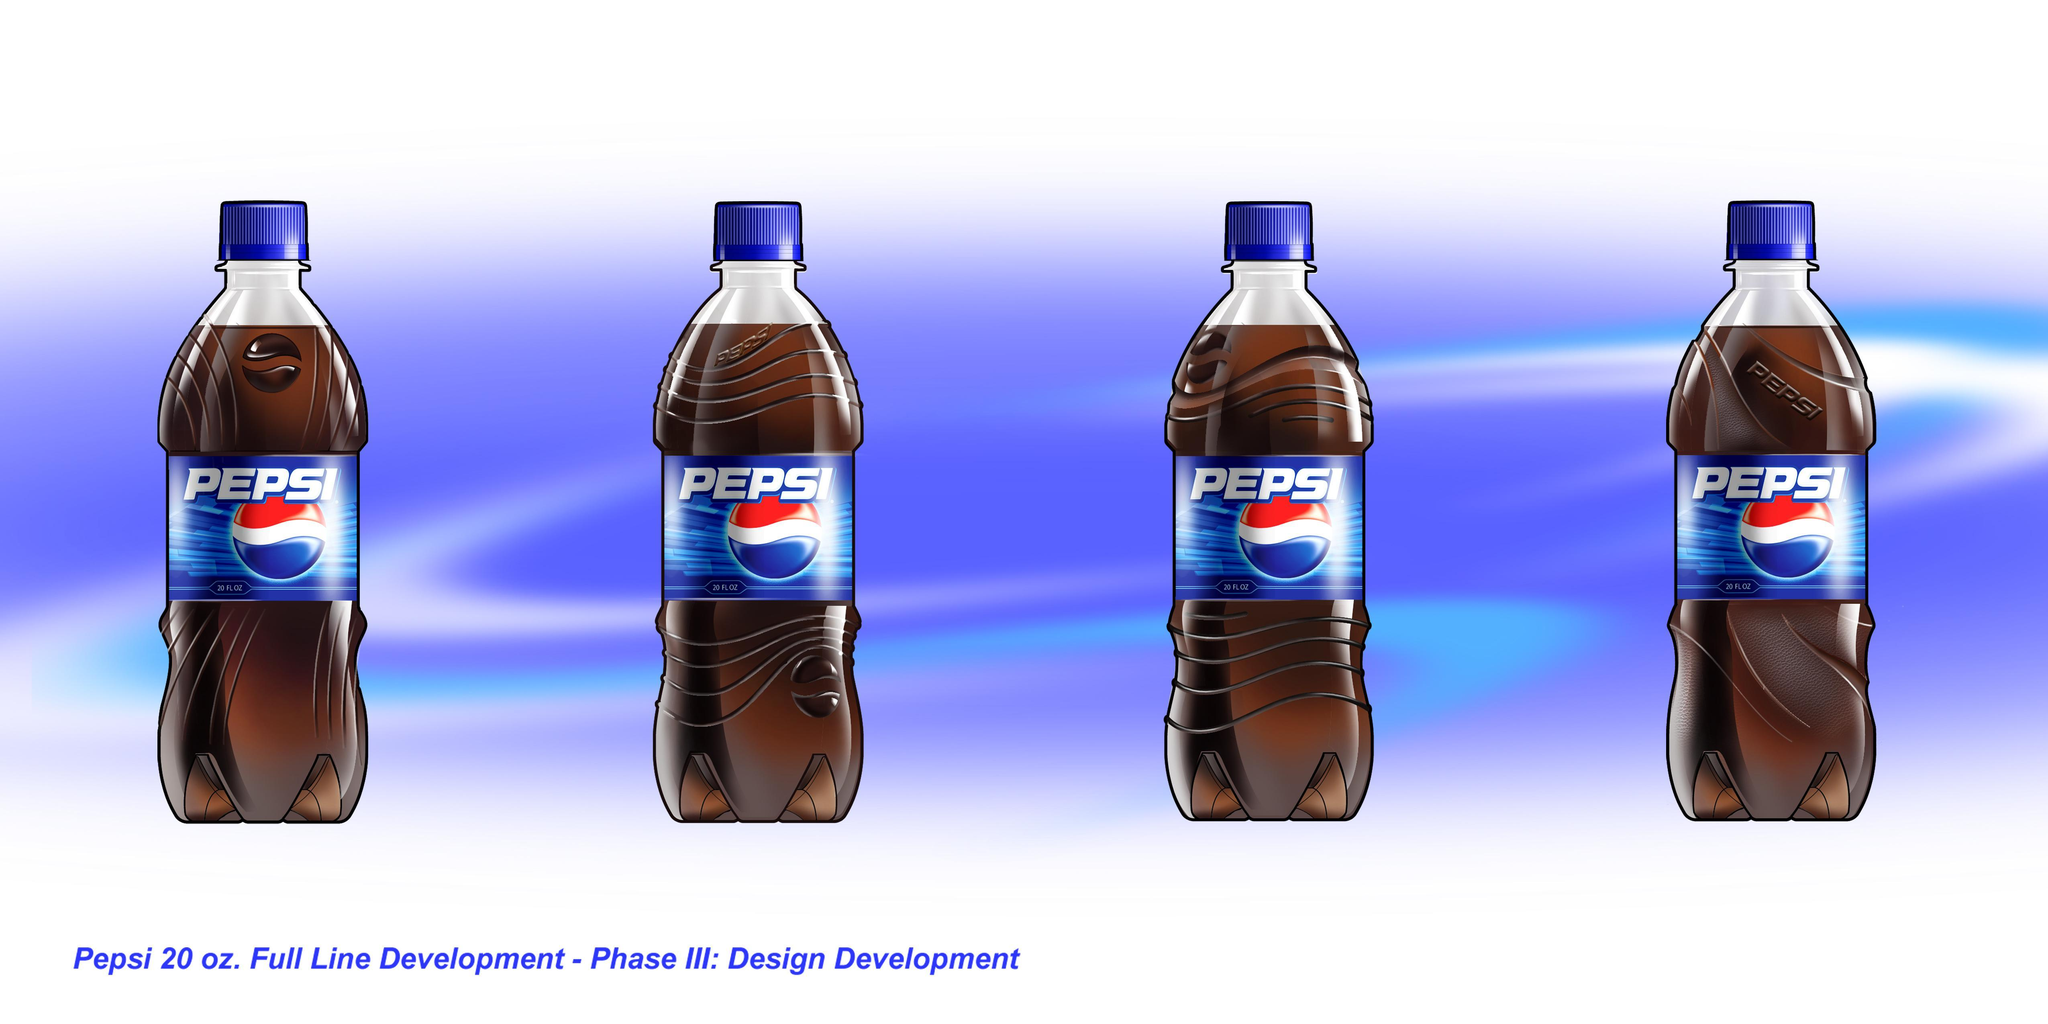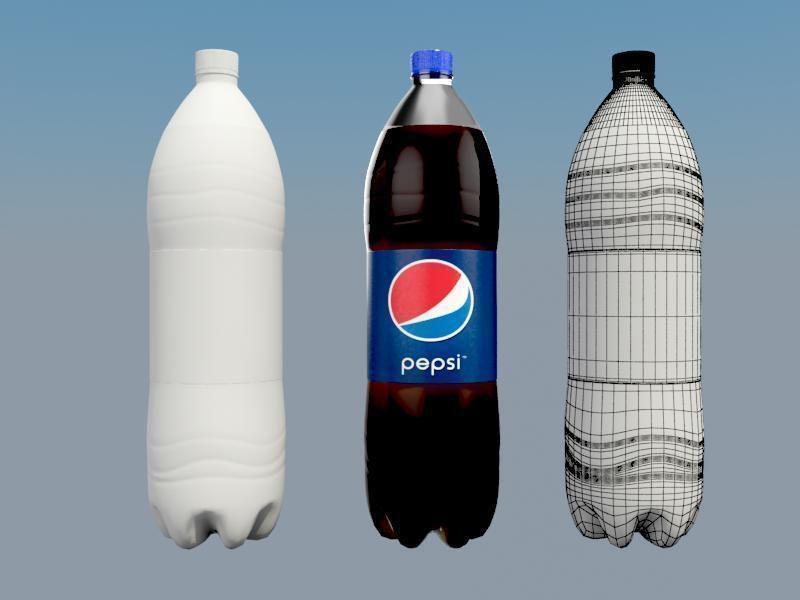The first image is the image on the left, the second image is the image on the right. Analyze the images presented: Is the assertion "One of the images has 3 bottles, while the other one has 4." valid? Answer yes or no. Yes. The first image is the image on the left, the second image is the image on the right. Given the left and right images, does the statement "There are exactly seven bottles." hold true? Answer yes or no. Yes. 